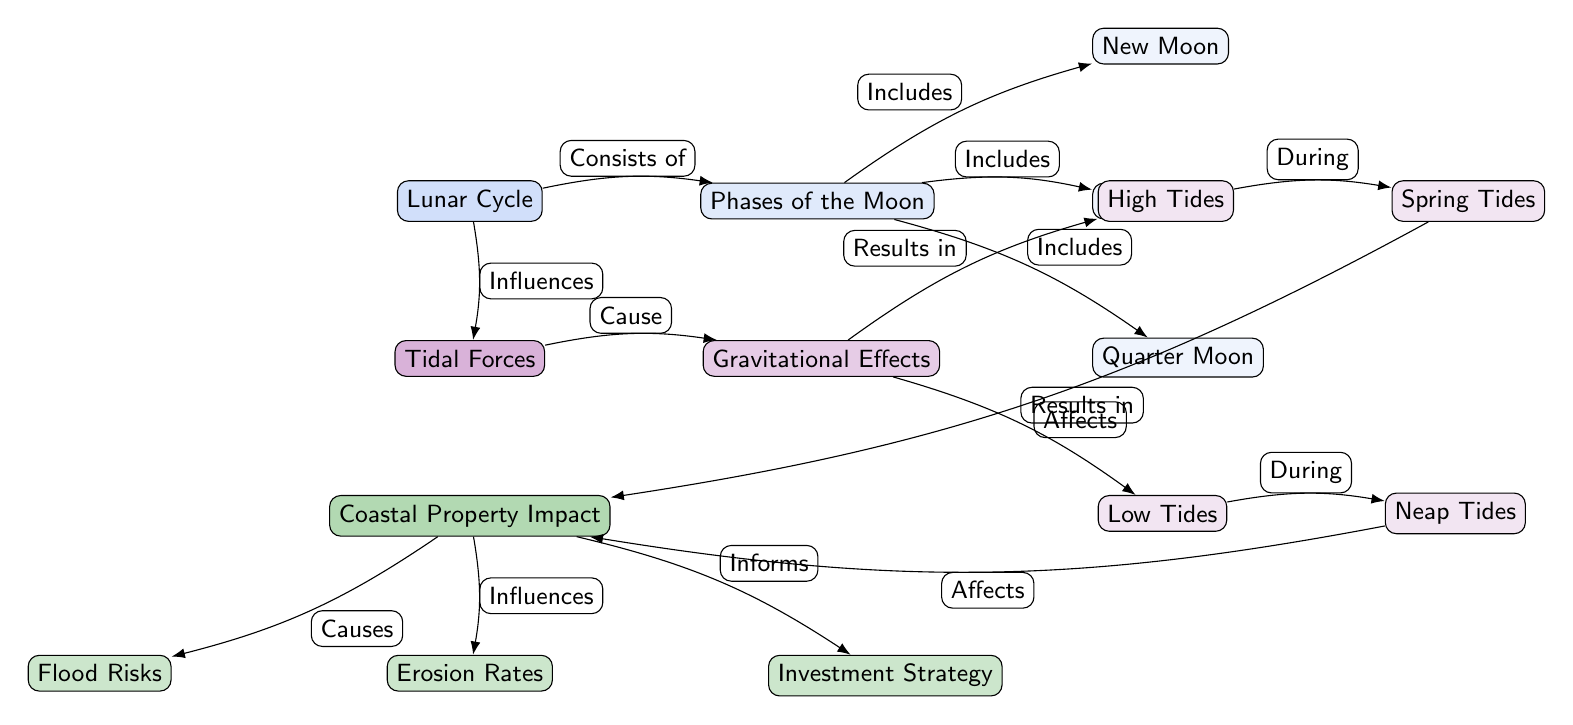What does the "Lunar Cycle" influence? The diagram states that the "Lunar Cycle" influences "Tidal Forces," indicated by the edge labeled "Influences" connecting those two nodes.
Answer: Tidal Forces How many phases of the moon are listed? The diagram lists three phases of the moon: New Moon, Full Moon, and Quarter Moon, as shown by the nodes connected to "Phases of the Moon."
Answer: 3 What type of tides occur during high tides? According to the diagram, "Spring Tides" occur during high tides, as indicated by the edge labeled "During" that connects "High Tides" to "Spring Tides."
Answer: Spring Tides What are the two types of tides mentioned? The two types of tides mentioned in the diagram are Spring Tides and Neap Tides, which are shown as results of gravitational effects on high and low tides.
Answer: Spring Tides, Neap Tides How does the "Lunar Cycle" affect "Coastal Property Impact"? The diagram shows that the "Lunar Cycle" influences "Tidal Forces," which then affects "Coastal Property Impact," indicated by the sequence of edges leading from the "Lunar Cycle" to "Tidal Forces" and then to "Coastal Property Impact."
Answer: Affects What causes "Flood Risks" according to the diagram? The diagram indicates that "Flood Risks" are caused by "Coastal Property Impact," shown by the edge labeled "Causes" connecting "Coastal Property Impact" to "Flood Risks."
Answer: Coastal Property Impact Which aspect of the tidal forces results in low tides? The diagram states that "Low Tides" are a result of gravitational effects on tidal forces, which is defined by the edge labeled "Results in" connecting "Gravitational Effects" to "Low Tides."
Answer: Gravitational Effects What impacts investment strategy in coastal properties? The diagram illustrates that "Investment Strategy" is informed by "Coastal Property Impact," which is shown by the edge labeled "Informs" connecting those two nodes.
Answer: Coastal Property Impact What is the relationship between "Quarter Moon" and the phases of the moon? The relationship is that "Quarter Moon" is one of the phases of the moon included in the node labeled "Phases of the Moon," indicated by the edge labeled "Includes."
Answer: Quarter Moon 